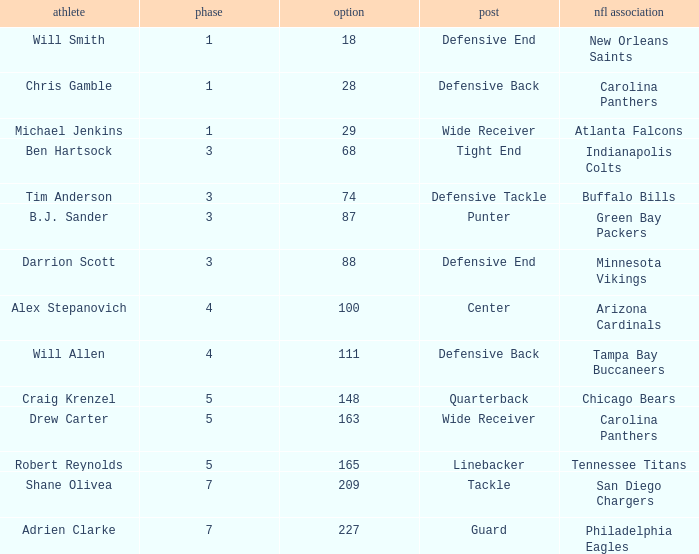What is the highest round number of a Pick after 209. 7.0. Give me the full table as a dictionary. {'header': ['athlete', 'phase', 'option', 'post', 'nfl association'], 'rows': [['Will Smith', '1', '18', 'Defensive End', 'New Orleans Saints'], ['Chris Gamble', '1', '28', 'Defensive Back', 'Carolina Panthers'], ['Michael Jenkins', '1', '29', 'Wide Receiver', 'Atlanta Falcons'], ['Ben Hartsock', '3', '68', 'Tight End', 'Indianapolis Colts'], ['Tim Anderson', '3', '74', 'Defensive Tackle', 'Buffalo Bills'], ['B.J. Sander', '3', '87', 'Punter', 'Green Bay Packers'], ['Darrion Scott', '3', '88', 'Defensive End', 'Minnesota Vikings'], ['Alex Stepanovich', '4', '100', 'Center', 'Arizona Cardinals'], ['Will Allen', '4', '111', 'Defensive Back', 'Tampa Bay Buccaneers'], ['Craig Krenzel', '5', '148', 'Quarterback', 'Chicago Bears'], ['Drew Carter', '5', '163', 'Wide Receiver', 'Carolina Panthers'], ['Robert Reynolds', '5', '165', 'Linebacker', 'Tennessee Titans'], ['Shane Olivea', '7', '209', 'Tackle', 'San Diego Chargers'], ['Adrien Clarke', '7', '227', 'Guard', 'Philadelphia Eagles']]} 